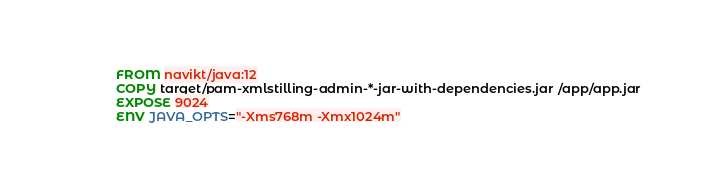Convert code to text. <code><loc_0><loc_0><loc_500><loc_500><_Dockerfile_>FROM navikt/java:12
COPY target/pam-xmlstilling-admin-*-jar-with-dependencies.jar /app/app.jar
EXPOSE 9024
ENV JAVA_OPTS="-Xms768m -Xmx1024m"
</code> 